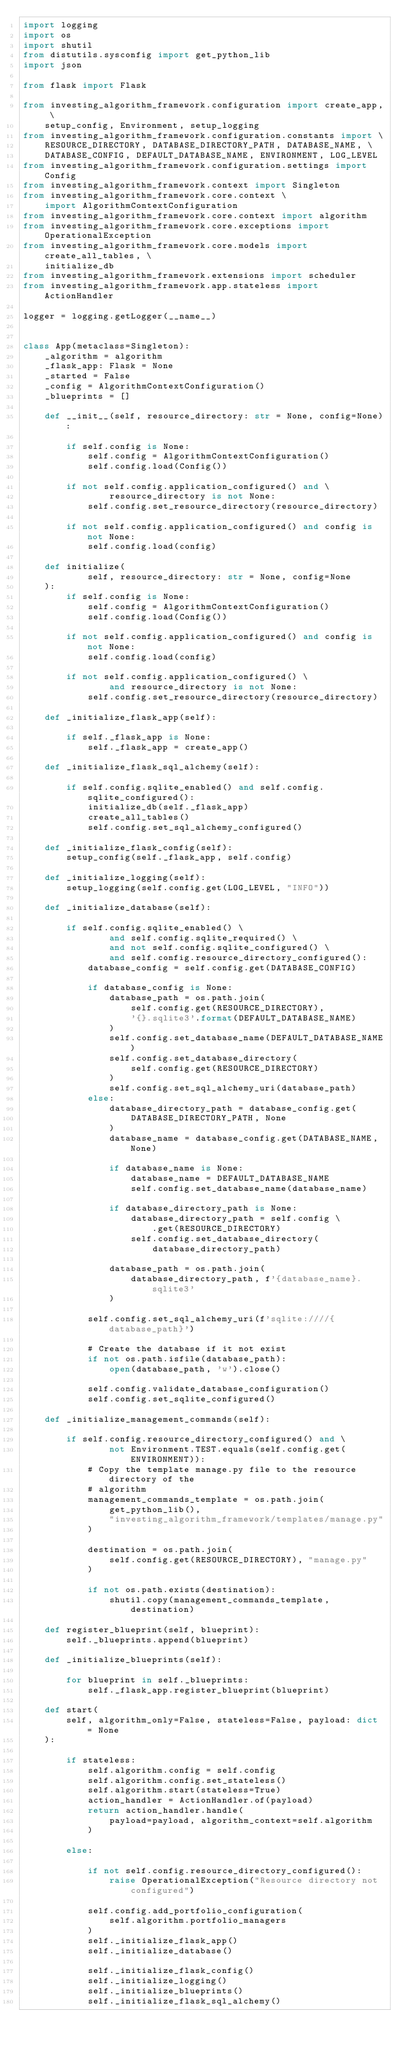Convert code to text. <code><loc_0><loc_0><loc_500><loc_500><_Python_>import logging
import os
import shutil
from distutils.sysconfig import get_python_lib
import json

from flask import Flask

from investing_algorithm_framework.configuration import create_app, \
    setup_config, Environment, setup_logging
from investing_algorithm_framework.configuration.constants import \
    RESOURCE_DIRECTORY, DATABASE_DIRECTORY_PATH, DATABASE_NAME, \
    DATABASE_CONFIG, DEFAULT_DATABASE_NAME, ENVIRONMENT, LOG_LEVEL
from investing_algorithm_framework.configuration.settings import Config
from investing_algorithm_framework.context import Singleton
from investing_algorithm_framework.core.context \
    import AlgorithmContextConfiguration
from investing_algorithm_framework.core.context import algorithm
from investing_algorithm_framework.core.exceptions import OperationalException
from investing_algorithm_framework.core.models import create_all_tables, \
    initialize_db
from investing_algorithm_framework.extensions import scheduler
from investing_algorithm_framework.app.stateless import ActionHandler

logger = logging.getLogger(__name__)


class App(metaclass=Singleton):
    _algorithm = algorithm
    _flask_app: Flask = None
    _started = False
    _config = AlgorithmContextConfiguration()
    _blueprints = []

    def __init__(self, resource_directory: str = None, config=None):

        if self.config is None:
            self.config = AlgorithmContextConfiguration()
            self.config.load(Config())

        if not self.config.application_configured() and \
                resource_directory is not None:
            self.config.set_resource_directory(resource_directory)

        if not self.config.application_configured() and config is not None:
            self.config.load(config)

    def initialize(
            self, resource_directory: str = None, config=None
    ):
        if self.config is None:
            self.config = AlgorithmContextConfiguration()
            self.config.load(Config())

        if not self.config.application_configured() and config is not None:
            self.config.load(config)

        if not self.config.application_configured() \
                and resource_directory is not None:
            self.config.set_resource_directory(resource_directory)

    def _initialize_flask_app(self):

        if self._flask_app is None:
            self._flask_app = create_app()

    def _initialize_flask_sql_alchemy(self):

        if self.config.sqlite_enabled() and self.config.sqlite_configured():
            initialize_db(self._flask_app)
            create_all_tables()
            self.config.set_sql_alchemy_configured()

    def _initialize_flask_config(self):
        setup_config(self._flask_app, self.config)

    def _initialize_logging(self):
        setup_logging(self.config.get(LOG_LEVEL, "INFO"))

    def _initialize_database(self):

        if self.config.sqlite_enabled() \
                and self.config.sqlite_required() \
                and not self.config.sqlite_configured() \
                and self.config.resource_directory_configured():
            database_config = self.config.get(DATABASE_CONFIG)

            if database_config is None:
                database_path = os.path.join(
                    self.config.get(RESOURCE_DIRECTORY),
                    '{}.sqlite3'.format(DEFAULT_DATABASE_NAME)
                )
                self.config.set_database_name(DEFAULT_DATABASE_NAME)
                self.config.set_database_directory(
                    self.config.get(RESOURCE_DIRECTORY)
                )
                self.config.set_sql_alchemy_uri(database_path)
            else:
                database_directory_path = database_config.get(
                    DATABASE_DIRECTORY_PATH, None
                )
                database_name = database_config.get(DATABASE_NAME, None)

                if database_name is None:
                    database_name = DEFAULT_DATABASE_NAME
                    self.config.set_database_name(database_name)

                if database_directory_path is None:
                    database_directory_path = self.config \
                        .get(RESOURCE_DIRECTORY)
                    self.config.set_database_directory(
                        database_directory_path)

                database_path = os.path.join(
                    database_directory_path, f'{database_name}.sqlite3'
                )

            self.config.set_sql_alchemy_uri(f'sqlite:////{database_path}')

            # Create the database if it not exist
            if not os.path.isfile(database_path):
                open(database_path, 'w').close()

            self.config.validate_database_configuration()
            self.config.set_sqlite_configured()

    def _initialize_management_commands(self):

        if self.config.resource_directory_configured() and \
                not Environment.TEST.equals(self.config.get(ENVIRONMENT)):
            # Copy the template manage.py file to the resource directory of the
            # algorithm
            management_commands_template = os.path.join(
                get_python_lib(),
                "investing_algorithm_framework/templates/manage.py"
            )

            destination = os.path.join(
                self.config.get(RESOURCE_DIRECTORY), "manage.py"
            )

            if not os.path.exists(destination):
                shutil.copy(management_commands_template, destination)

    def register_blueprint(self, blueprint):
        self._blueprints.append(blueprint)

    def _initialize_blueprints(self):

        for blueprint in self._blueprints:
            self._flask_app.register_blueprint(blueprint)

    def start(
        self, algorithm_only=False, stateless=False, payload: dict = None
    ):

        if stateless:
            self.algorithm.config = self.config
            self.algorithm.config.set_stateless()
            self.algorithm.start(stateless=True)
            action_handler = ActionHandler.of(payload)
            return action_handler.handle(
                payload=payload, algorithm_context=self.algorithm
            )

        else:

            if not self.config.resource_directory_configured():
                raise OperationalException("Resource directory not configured")

            self.config.add_portfolio_configuration(
                self.algorithm.portfolio_managers
            )
            self._initialize_flask_app()
            self._initialize_database()

            self._initialize_flask_config()
            self._initialize_logging()
            self._initialize_blueprints()
            self._initialize_flask_sql_alchemy()</code> 